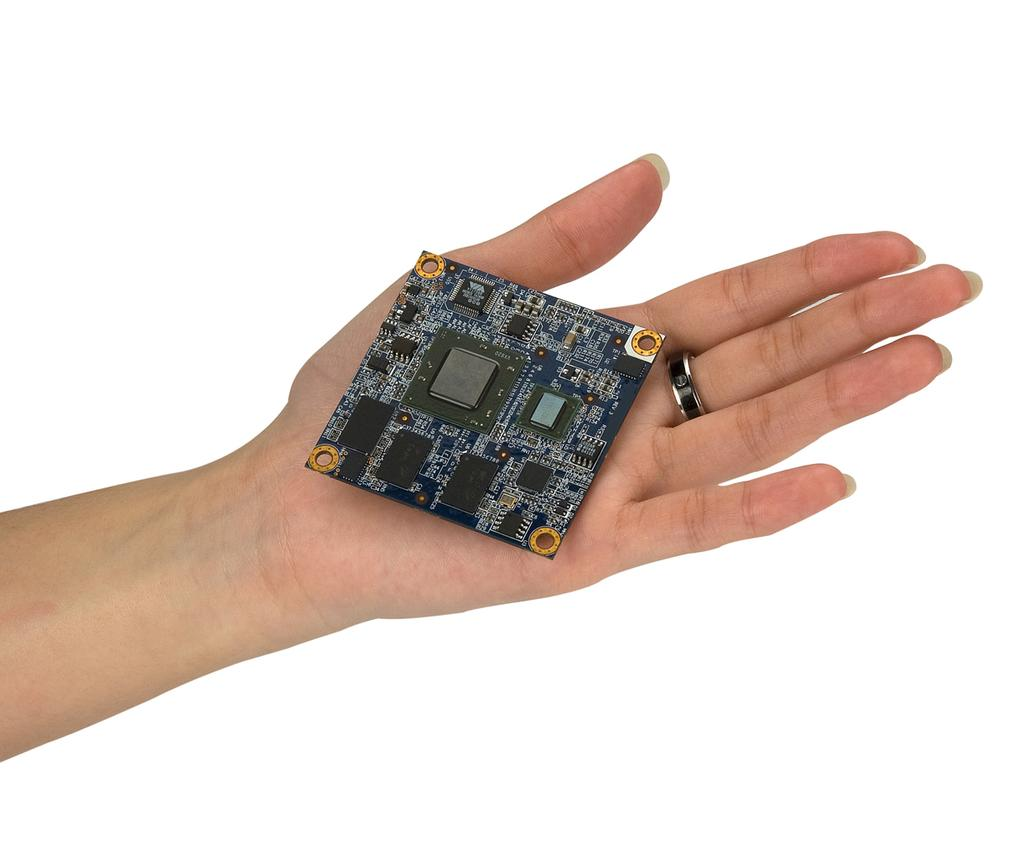What part of a person is visible in the image? There is a hand of a person in the image. What type of jewelry is worn on the hand? A ring is visible on the middle finger of the hand. What is the setting or object in the image? There is a cheap in the image. What color is the background of the image? The background of the image is white in color. How many sheep are visible in the image? There are no sheep present in the image. What type of animal can be seen interacting with the cheap in the image? There are no animals present in the image; it only features a hand with a ring and a cheap. 